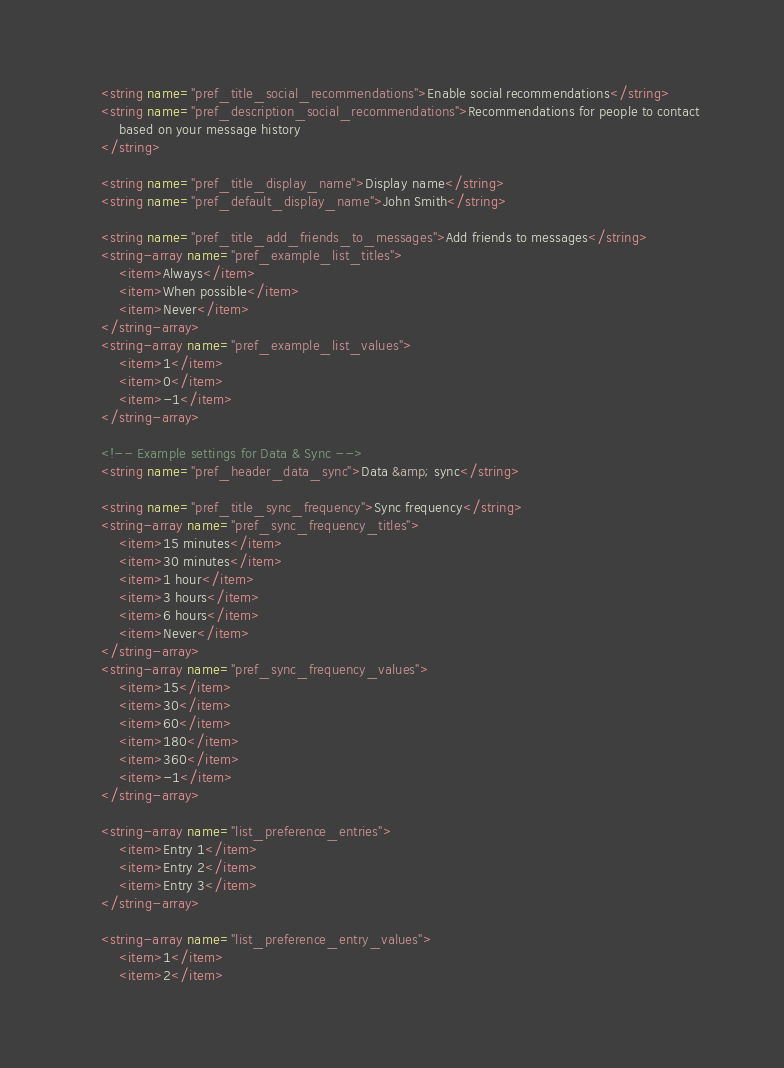Convert code to text. <code><loc_0><loc_0><loc_500><loc_500><_XML_>    <string name="pref_title_social_recommendations">Enable social recommendations</string>
    <string name="pref_description_social_recommendations">Recommendations for people to contact
        based on your message history
    </string>

    <string name="pref_title_display_name">Display name</string>
    <string name="pref_default_display_name">John Smith</string>

    <string name="pref_title_add_friends_to_messages">Add friends to messages</string>
    <string-array name="pref_example_list_titles">
        <item>Always</item>
        <item>When possible</item>
        <item>Never</item>
    </string-array>
    <string-array name="pref_example_list_values">
        <item>1</item>
        <item>0</item>
        <item>-1</item>
    </string-array>

    <!-- Example settings for Data & Sync -->
    <string name="pref_header_data_sync">Data &amp; sync</string>

    <string name="pref_title_sync_frequency">Sync frequency</string>
    <string-array name="pref_sync_frequency_titles">
        <item>15 minutes</item>
        <item>30 minutes</item>
        <item>1 hour</item>
        <item>3 hours</item>
        <item>6 hours</item>
        <item>Never</item>
    </string-array>
    <string-array name="pref_sync_frequency_values">
        <item>15</item>
        <item>30</item>
        <item>60</item>
        <item>180</item>
        <item>360</item>
        <item>-1</item>
    </string-array>

    <string-array name="list_preference_entries">
        <item>Entry 1</item>
        <item>Entry 2</item>
        <item>Entry 3</item>
    </string-array>

    <string-array name="list_preference_entry_values">
        <item>1</item>
        <item>2</item></code> 